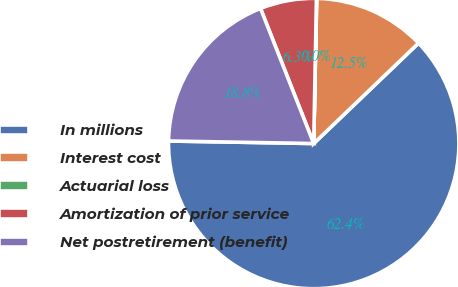Convert chart to OTSL. <chart><loc_0><loc_0><loc_500><loc_500><pie_chart><fcel>In millions<fcel>Interest cost<fcel>Actuarial loss<fcel>Amortization of prior service<fcel>Net postretirement (benefit)<nl><fcel>62.43%<fcel>12.51%<fcel>0.03%<fcel>6.27%<fcel>18.75%<nl></chart> 